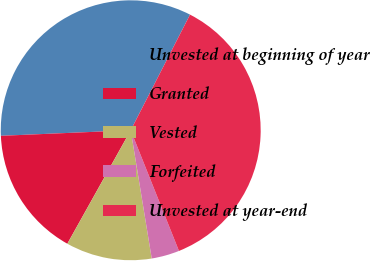<chart> <loc_0><loc_0><loc_500><loc_500><pie_chart><fcel>Unvested at beginning of year<fcel>Granted<fcel>Vested<fcel>Forfeited<fcel>Unvested at year-end<nl><fcel>33.22%<fcel>16.21%<fcel>10.69%<fcel>3.47%<fcel>36.4%<nl></chart> 